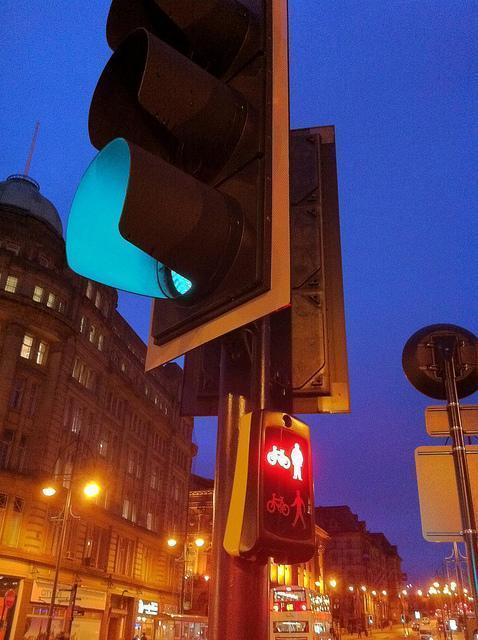How many traffic lights are there?
Give a very brief answer. 3. 